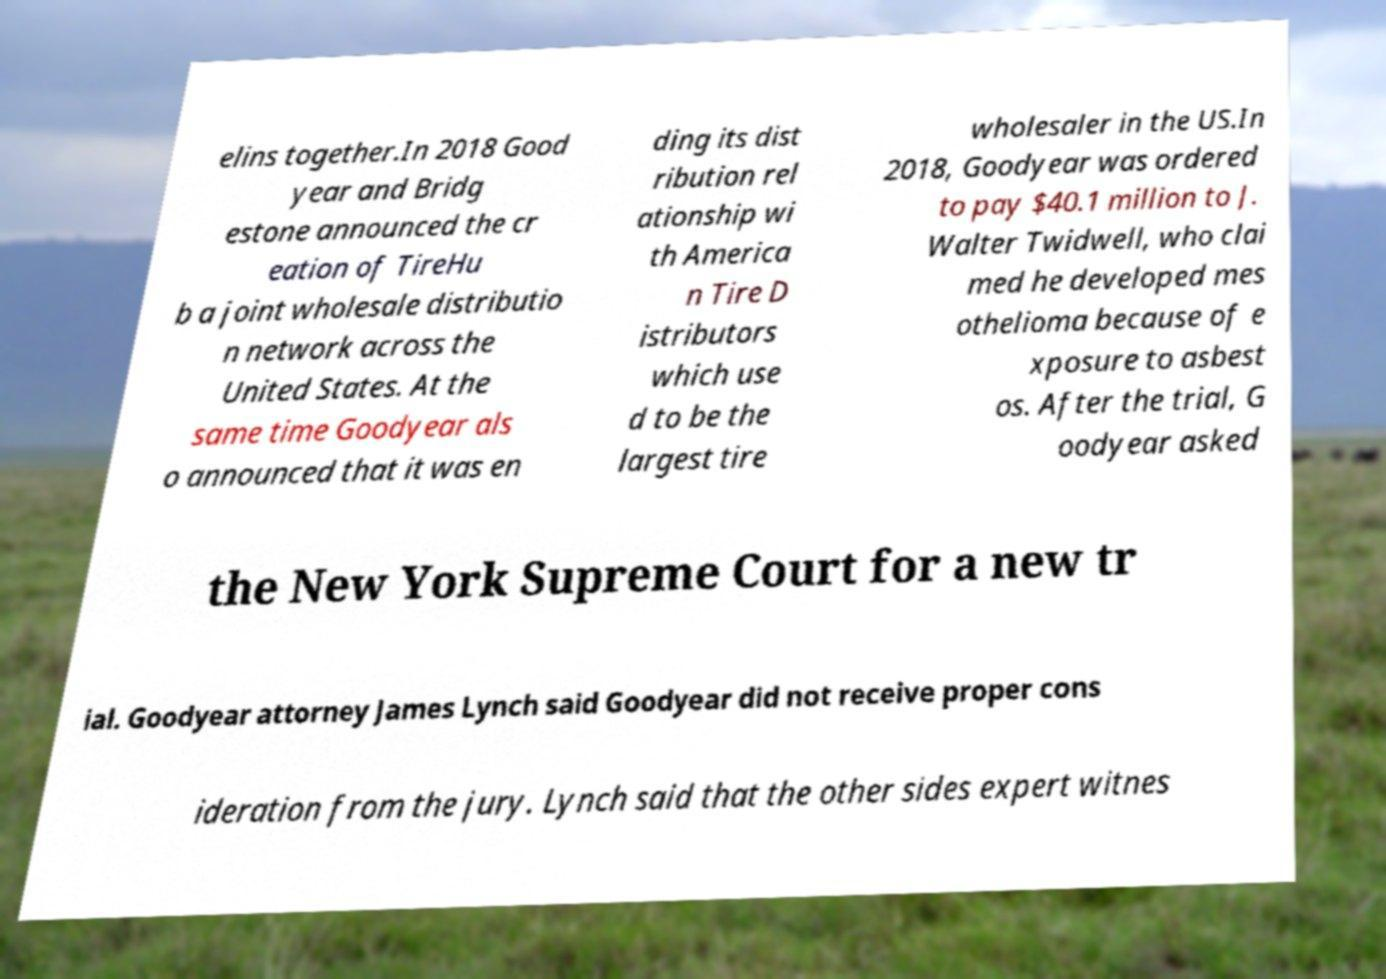Please read and relay the text visible in this image. What does it say? elins together.In 2018 Good year and Bridg estone announced the cr eation of TireHu b a joint wholesale distributio n network across the United States. At the same time Goodyear als o announced that it was en ding its dist ribution rel ationship wi th America n Tire D istributors which use d to be the largest tire wholesaler in the US.In 2018, Goodyear was ordered to pay $40.1 million to J. Walter Twidwell, who clai med he developed mes othelioma because of e xposure to asbest os. After the trial, G oodyear asked the New York Supreme Court for a new tr ial. Goodyear attorney James Lynch said Goodyear did not receive proper cons ideration from the jury. Lynch said that the other sides expert witnes 